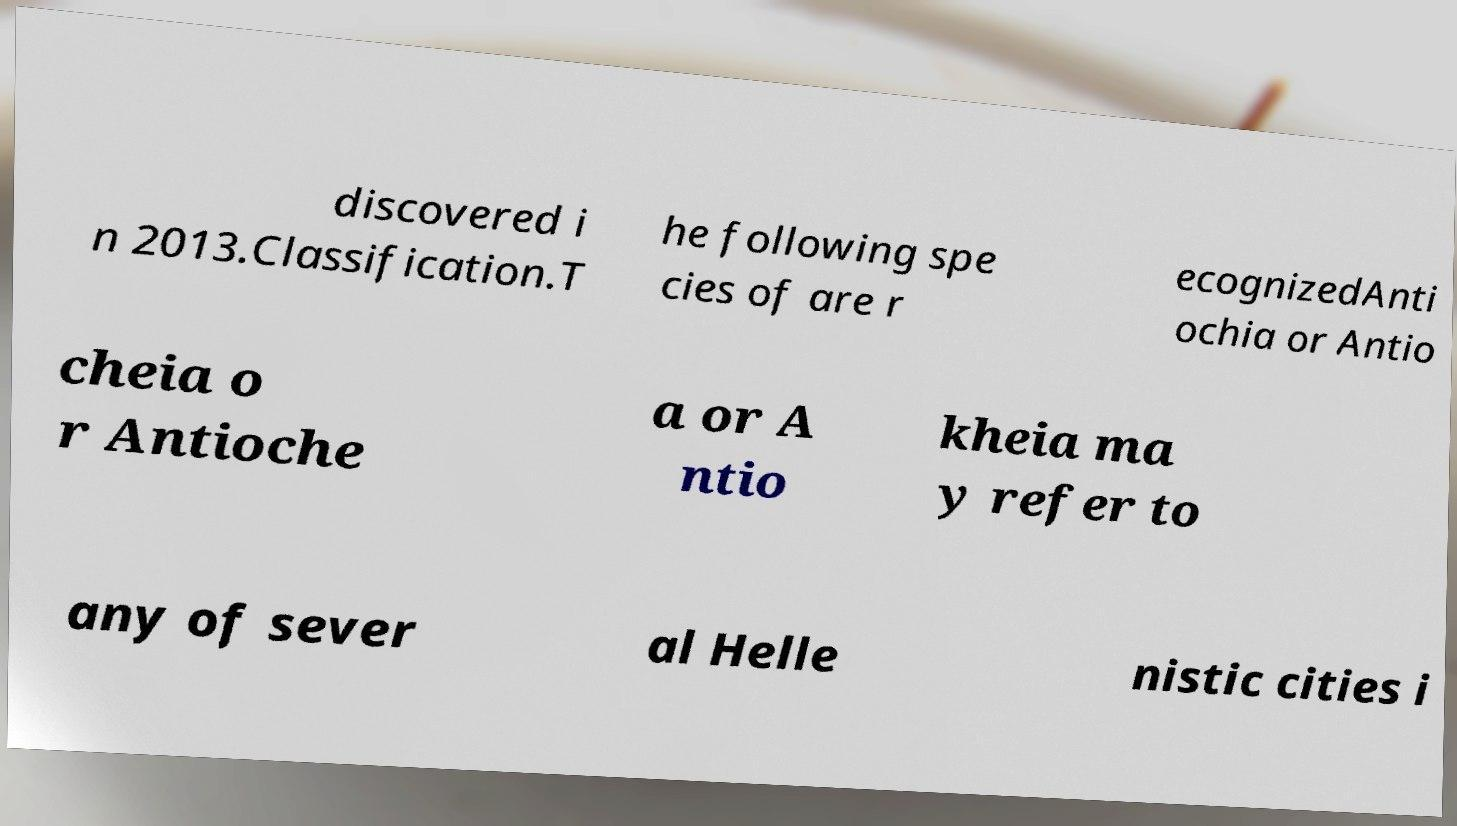For documentation purposes, I need the text within this image transcribed. Could you provide that? discovered i n 2013.Classification.T he following spe cies of are r ecognizedAnti ochia or Antio cheia o r Antioche a or A ntio kheia ma y refer to any of sever al Helle nistic cities i 